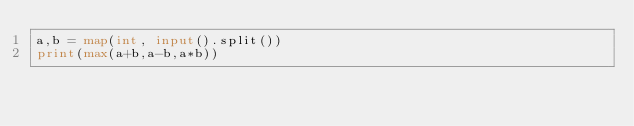<code> <loc_0><loc_0><loc_500><loc_500><_Python_>a,b = map(int, input().split())
print(max(a+b,a-b,a*b))</code> 